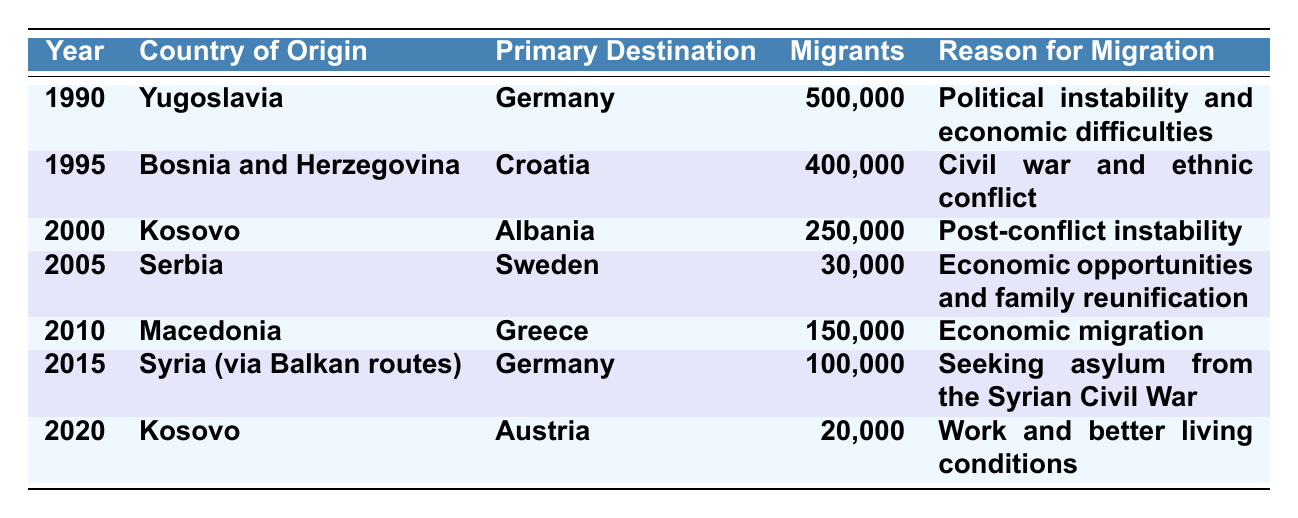What was the primary destination for migrants from Yugoslavia in 1990? The table shows that the primary destination for migrants from Yugoslavia in 1990 was Germany.
Answer: Germany How many migrants moved from Bosnia and Herzegovina in 1995? From the table, it is stated that 400,000 migrants moved from Bosnia and Herzegovina in 1995.
Answer: 400,000 What is the total number of migrants recorded in the table from 1990 to 2020? The total number is calculated by adding all migrant numbers: 500,000 + 400,000 + 250,000 + 30,000 + 150,000 + 100,000 + 20,000 = 1,450,000.
Answer: 1,450,000 Which country had the highest number of migrants in the year 1990? The table indicates that Yugoslavia had the highest number of migrants in 1990, with 500,000 migrants moving to Germany.
Answer: Yugoslavia Was there any migration from Kosovo in the year 2005? The table shows that there were no records of migration from Kosovo in 2005; the origin country listed for that year is Serbia.
Answer: No In which year did the number of migrants from Syria via Balkan routes surpass 100,000? The table presents data for 2015, where the number of migrants from Syria via Balkan routes was 100,000, which is not surpassed by any other year in the table for this specific country.
Answer: 2015 What reasons for migration are mentioned for Kosovo migrants in the years 2000 and 2020? The table shows that in 2000, migrants from Kosovo moved to Albania due to post-conflict instability, and in 2020, they moved to Austria for work and better living conditions.
Answer: Post-conflict instability; Work and better living conditions How many more migrants moved from Bosnia and Herzegovina than from Serbia in 2005? From the table, 400,000 migrants moved from Bosnia and Herzegovina and 30,000 from Serbia in 2005. Subtracting gives 400,000 - 30,000 = 370,000.
Answer: 370,000 Which two countries had migration data recorded in the same year of 2010? The table shows that in 2010, there were migrants from Macedonia to Greece. This is the only record for that year.
Answer: Macedonia to Greece Was the reason for migration from Kosovo consistent in both 2000 and 2020? The reasons are different; in 2000 it was for post-conflict instability, while in 2020 it was for work and better living conditions.
Answer: No 